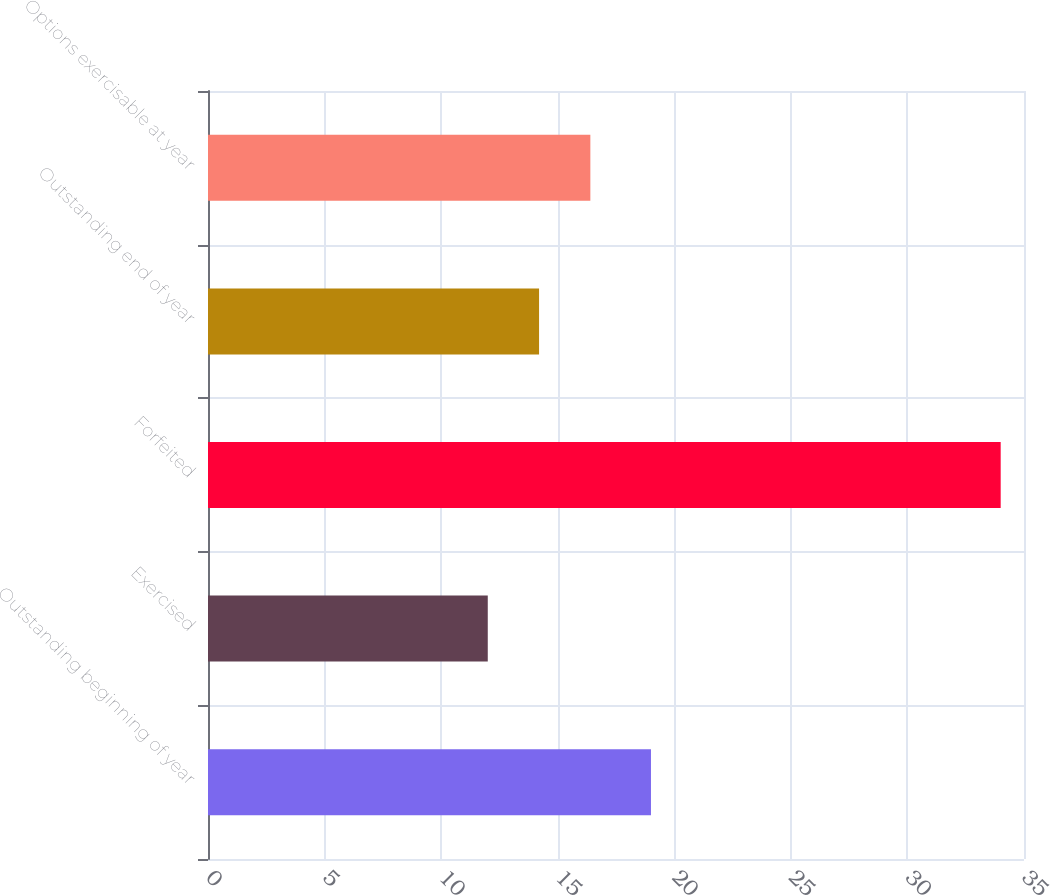Convert chart to OTSL. <chart><loc_0><loc_0><loc_500><loc_500><bar_chart><fcel>Outstanding beginning of year<fcel>Exercised<fcel>Forfeited<fcel>Outstanding end of year<fcel>Options exercisable at year<nl><fcel>19<fcel>12<fcel>34<fcel>14.2<fcel>16.4<nl></chart> 